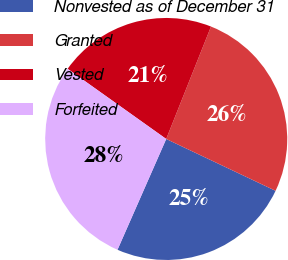Convert chart. <chart><loc_0><loc_0><loc_500><loc_500><pie_chart><fcel>Nonvested as of December 31<fcel>Granted<fcel>Vested<fcel>Forfeited<nl><fcel>24.55%<fcel>26.01%<fcel>21.19%<fcel>28.25%<nl></chart> 